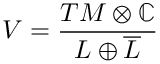<formula> <loc_0><loc_0><loc_500><loc_500>V = { \frac { T M \otimes \mathbb { C } } { L \oplus { \overline { L } } } }</formula> 